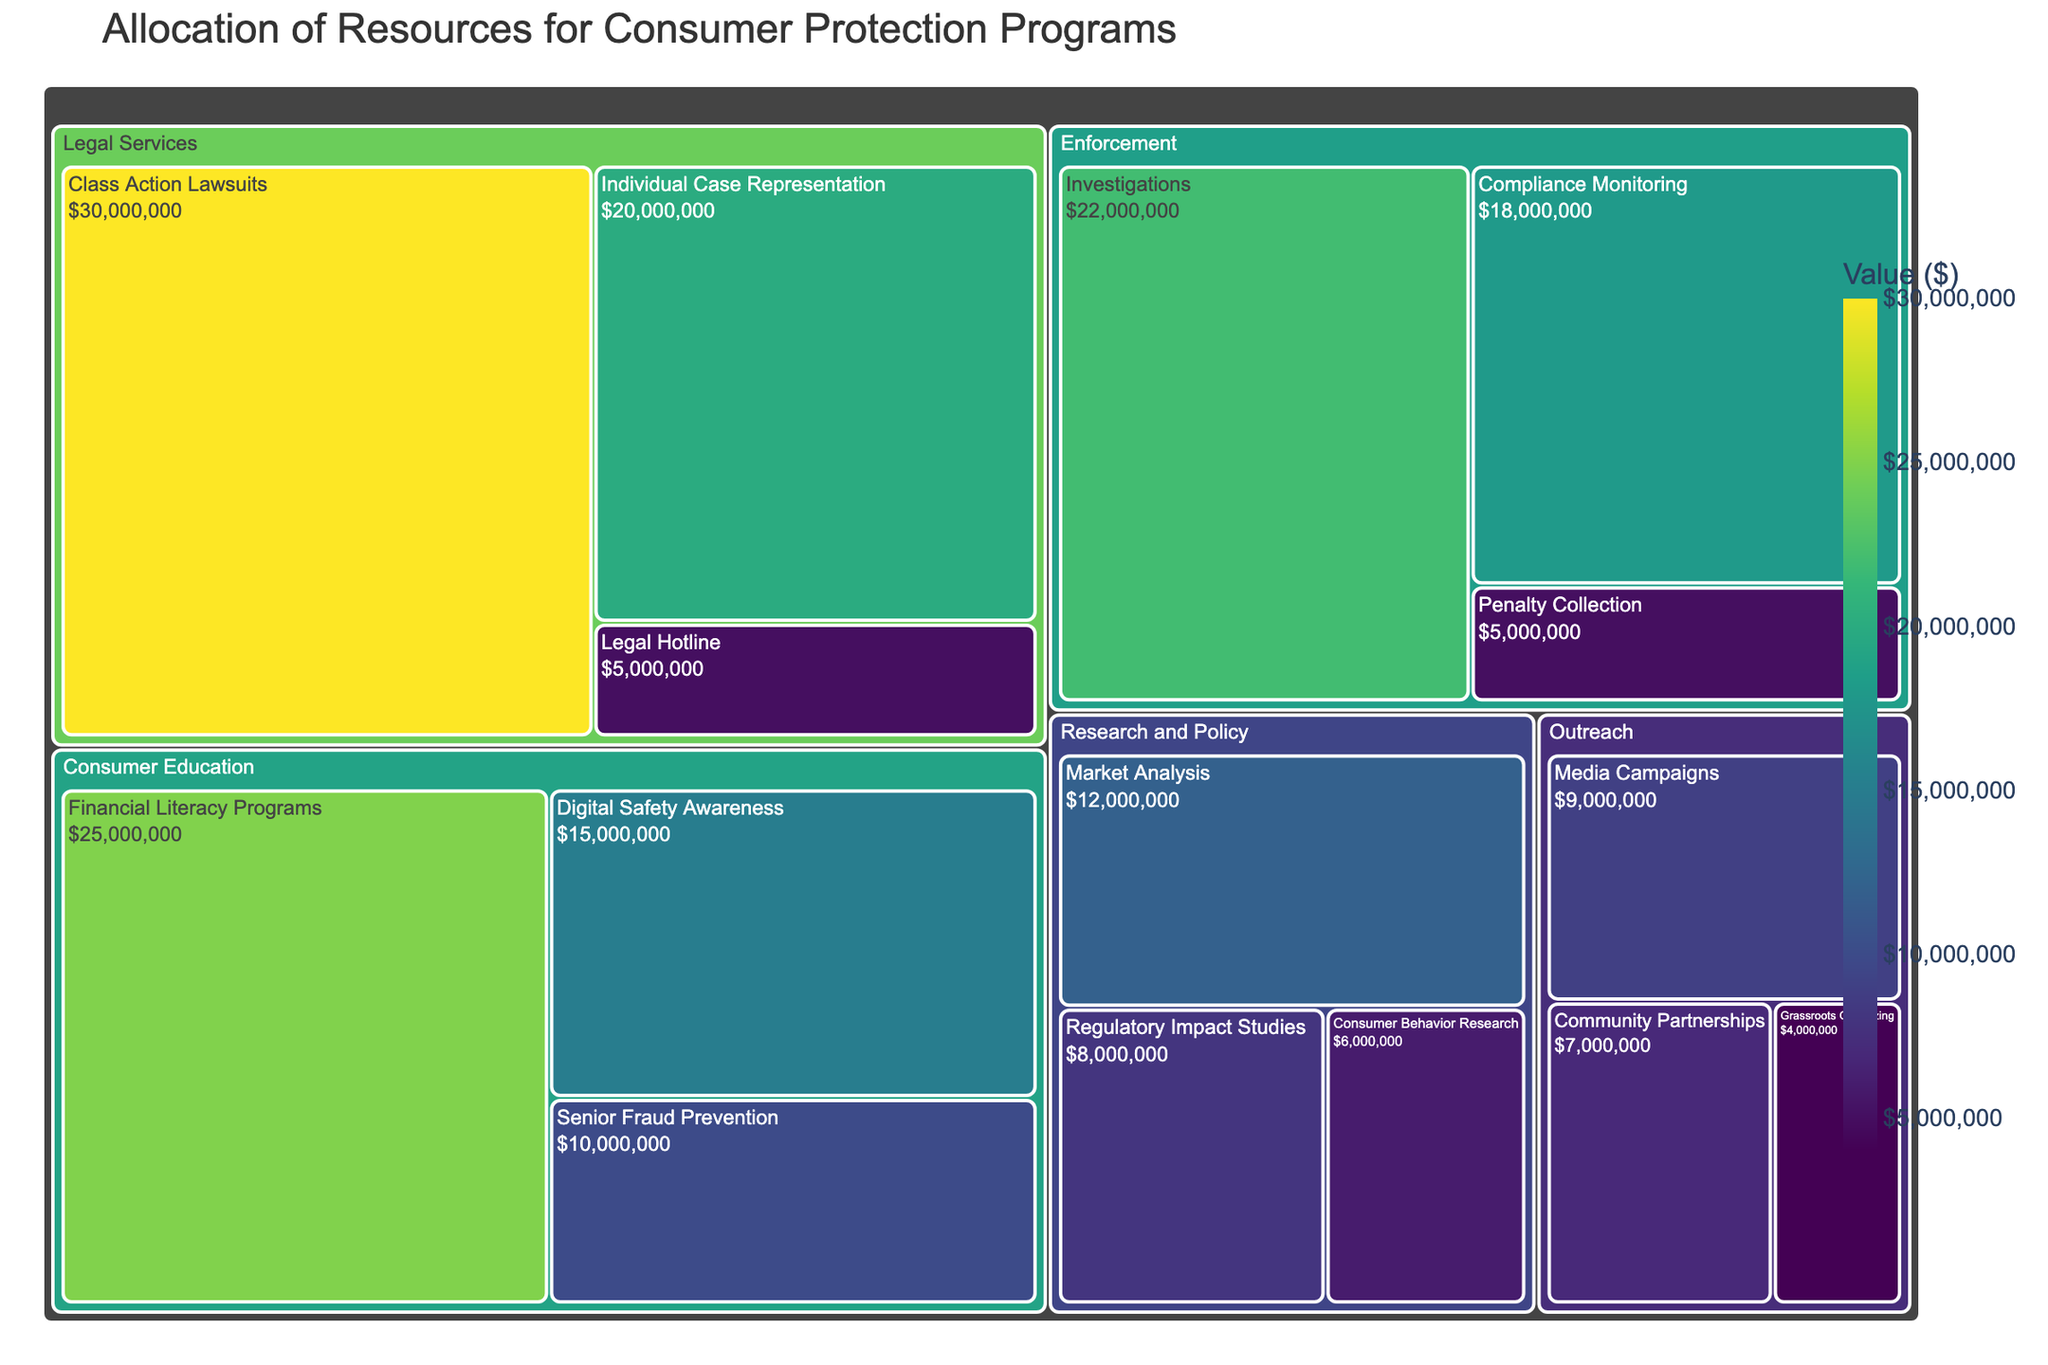What's the total value allocated to Consumer Education programs? Sum the values for all subcategories within the Consumer Education category: $25,000,000 (Financial Literacy Programs) + $15,000,000 (Digital Safety Awareness) + $10,000,000 (Senior Fraud Prevention) = $50,000,000
Answer: $50,000,000 Which subcategory within Legal Services has the highest allocation? Compare the values for all subcategories within Legal Services: Class Action Lawsuits ($30,000,000), Individual Case Representation ($20,000,000), and Legal Hotline ($5,000,000). The highest value is $30,000,000 for Class Action Lawsuits
Answer: Class Action Lawsuits How does the total allocation for Enforcement compare to the total allocation for Outreach? Sum the values for Enforcement: $22,000,000 (Investigations) + $18,000,000 (Compliance Monitoring) + $5,000,000 (Penalty Collection) = $45,000,000. Sum the values for Outreach: $7,000,000 (Community Partnerships) + $9,000,000 (Media Campaigns) + $4,000,000 (Grassroots Organizing) = $20,000,000. Enforcement ($45,000,000) is $25,000,000 more than Outreach ($20,000,000)
Answer: Enforcement has $25,000,000 more What is the smallest allocated subcategory and its value? Identify the smallest value among all subcategories: Penalty Collection ($5,000,000), Legal Hotline ($5,000,000), Grassroots Organizing ($4,000,000). Grassroots Organizing has the smallest value
Answer: Grassroots Organizing, $4,000,000 What's the combined allocation for Research and Policy categories? Sum the values for all subcategories within Research and Policy: $12,000,000 (Market Analysis) + $8,000,000 (Regulatory Impact Studies) + $6,000,000 (Consumer Behavior Research) = $26,000,000
Answer: $26,000,000 Which category has the highest single subcategory allocation and what is it? Compare all single subcategory allocations: Financial Literacy Programs ($25,000,000), Digital Safety Awareness ($15,000,000), Senior Fraud Prevention ($10,000,000), Class Action Lawsuits ($30,000,000), Individual Case Representation ($20,000,000), Legal Hotline ($5,000,000), Market Analysis ($12,000,000), Regulatory Impact Studies ($8,000,000), Consumer Behavior Research ($6,000,000), Investigations ($22,000,000), Compliance Monitoring ($18,000,000), Penalty Collection ($5,000,000), Community Partnerships ($7,000,000), Media Campaigns ($9,000,000), Grassroots Organizing ($4,000,000). The highest value is $30,000,000 for Class Action Lawsuits within Legal Services
Answer: Legal Services, Class Action Lawsuits, $30,000,000 How much more is allocated to Class Action Lawsuits compared to Market Analysis? Subtract the value for Market Analysis from the value for Class Action Lawsuits: $30,000,000 (Class Action Lawsuits) - $12,000,000 (Market Analysis) = $18,000,000
Answer: $18,000,000 What percentage of the total budget is allocated to Digital Safety Awareness programs? Calculate the total budget first by summing up all values: $25,000,000 + $15,000,000 + $10,000,000 + $30,000,000 + $20,000,000 + $5,000,000 + $12,000,000 + $8,000,000 + $6,000,000 + $22,000,000 + $18,000,000 + $5,000,000 + $7,000,000 + $9,000,000 + $4,000,000 = $196,000,000. Then calculate the percentage: ($15,000,000 / $196,000,000) * 100% = 7.65%
Answer: 7.65% 